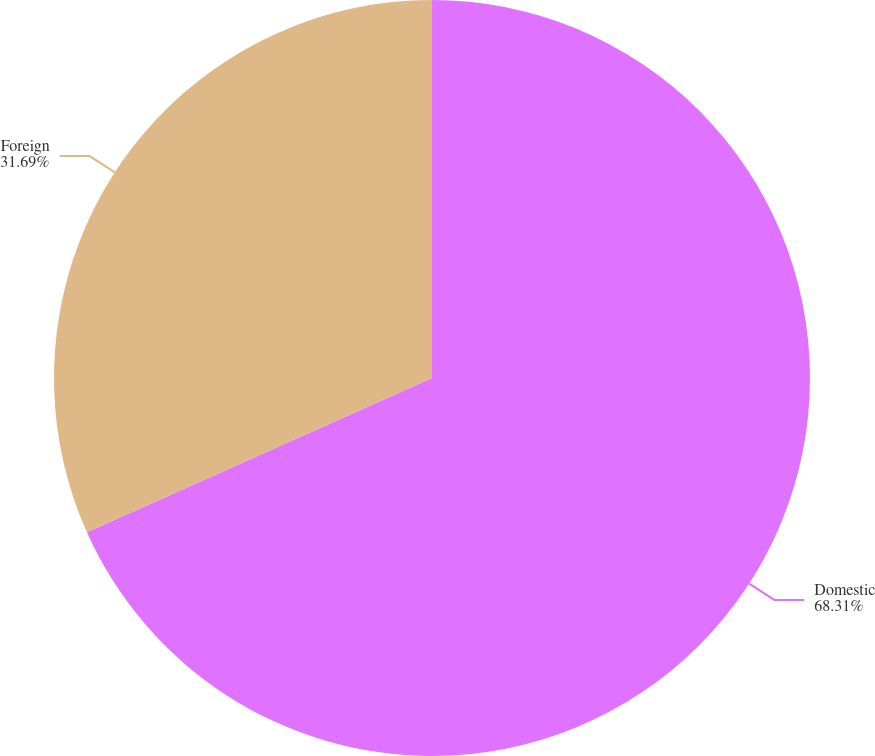Convert chart. <chart><loc_0><loc_0><loc_500><loc_500><pie_chart><fcel>Domestic<fcel>Foreign<nl><fcel>68.31%<fcel>31.69%<nl></chart> 